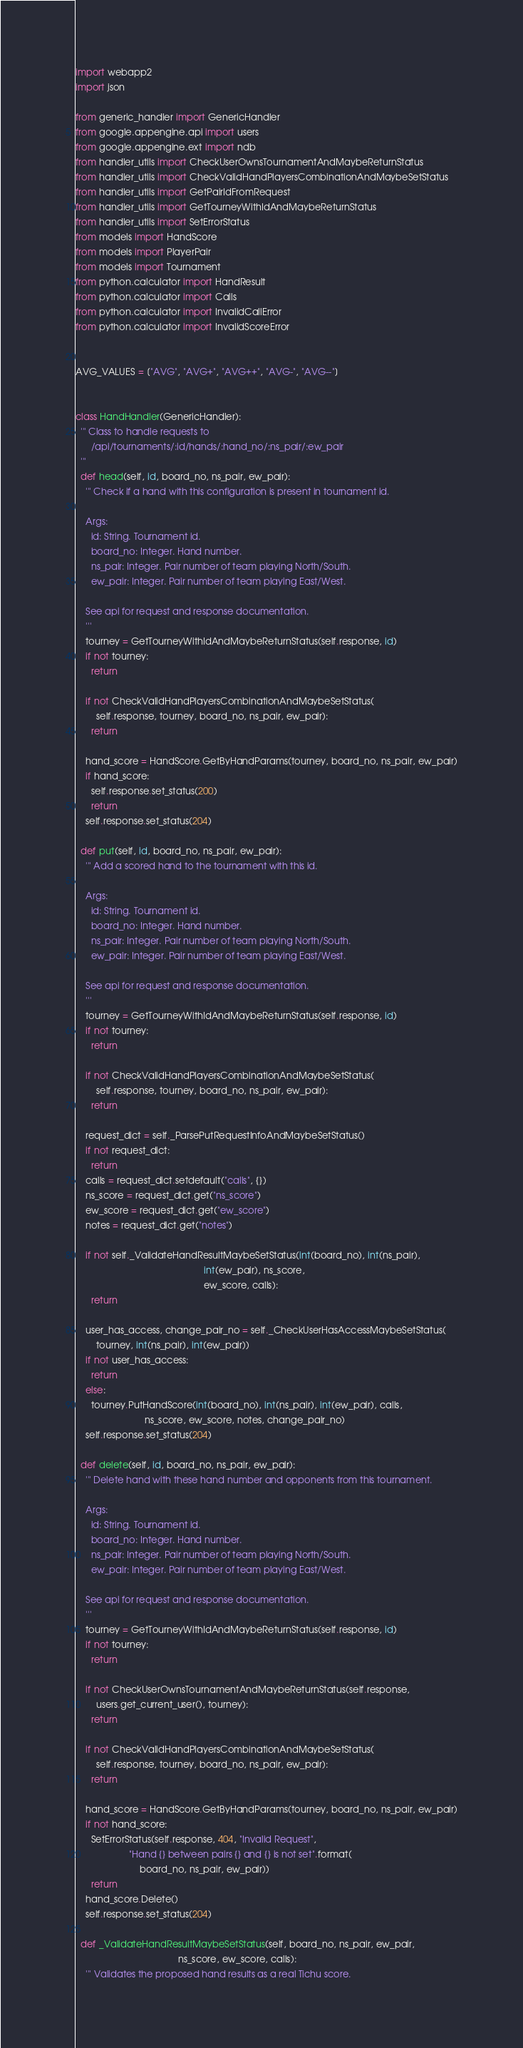Convert code to text. <code><loc_0><loc_0><loc_500><loc_500><_Python_>import webapp2
import json

from generic_handler import GenericHandler
from google.appengine.api import users
from google.appengine.ext import ndb
from handler_utils import CheckUserOwnsTournamentAndMaybeReturnStatus
from handler_utils import CheckValidHandPlayersCombinationAndMaybeSetStatus
from handler_utils import GetPairIdFromRequest
from handler_utils import GetTourneyWithIdAndMaybeReturnStatus
from handler_utils import SetErrorStatus
from models import HandScore
from models import PlayerPair
from models import Tournament
from python.calculator import HandResult
from python.calculator import Calls
from python.calculator import InvalidCallError
from python.calculator import InvalidScoreError


AVG_VALUES = ["AVG", "AVG+", "AVG++", "AVG-", "AVG--"]


class HandHandler(GenericHandler):
  ''' Class to handle requests to 
      /api/tournaments/:id/hands/:hand_no/:ns_pair/:ew_pair
  '''
  def head(self, id, board_no, ns_pair, ew_pair):
    ''' Check if a hand with this configuration is present in tournament id. 

    Args:
      id: String. Tournament id. 
      board_no: Integer. Hand number.
      ns_pair: Integer. Pair number of team playing North/South.
      ew_pair: Integer. Pair number of team playing East/West.

    See api for request and response documentation.
    '''
    tourney = GetTourneyWithIdAndMaybeReturnStatus(self.response, id)
    if not tourney:
      return

    if not CheckValidHandPlayersCombinationAndMaybeSetStatus(
        self.response, tourney, board_no, ns_pair, ew_pair):
      return

    hand_score = HandScore.GetByHandParams(tourney, board_no, ns_pair, ew_pair)
    if hand_score:
      self.response.set_status(200)
      return 
    self.response.set_status(204)

  def put(self, id, board_no, ns_pair, ew_pair):
    ''' Add a scored hand to the tournament with this id. 

    Args:
      id: String. Tournament id. 
      board_no: Integer. Hand number.
      ns_pair: Integer. Pair number of team playing North/South.
      ew_pair: Integer. Pair number of team playing East/West.
    
    See api for request and response documentation.
    '''
    tourney = GetTourneyWithIdAndMaybeReturnStatus(self.response, id)
    if not tourney:
      return

    if not CheckValidHandPlayersCombinationAndMaybeSetStatus(
        self.response, tourney, board_no, ns_pair, ew_pair):
      return

    request_dict = self._ParsePutRequestInfoAndMaybeSetStatus()
    if not request_dict:
      return
    calls = request_dict.setdefault("calls", {})
    ns_score = request_dict.get("ns_score")
    ew_score = request_dict.get("ew_score")
    notes = request_dict.get("notes")

    if not self._ValidateHandResultMaybeSetStatus(int(board_no), int(ns_pair),
                                                  int(ew_pair), ns_score,
                                                  ew_score, calls):
      return

    user_has_access, change_pair_no = self._CheckUserHasAccessMaybeSetStatus(
        tourney, int(ns_pair), int(ew_pair))
    if not user_has_access:
      return
    else:
      tourney.PutHandScore(int(board_no), int(ns_pair), int(ew_pair), calls,
                           ns_score, ew_score, notes, change_pair_no)
    self.response.set_status(204)

  def delete(self, id, board_no, ns_pair, ew_pair):
    ''' Delete hand with these hand number and opponents from this tournament.

    Args:
      id: String. Tournament id. 
      board_no: Integer. Hand number.
      ns_pair: Integer. Pair number of team playing North/South.
      ew_pair: Integer. Pair number of team playing East/West.
    
    See api for request and response documentation.
    '''
    tourney = GetTourneyWithIdAndMaybeReturnStatus(self.response, id)
    if not tourney:
      return

    if not CheckUserOwnsTournamentAndMaybeReturnStatus(self.response,
        users.get_current_user(), tourney):
      return

    if not CheckValidHandPlayersCombinationAndMaybeSetStatus(
        self.response, tourney, board_no, ns_pair, ew_pair):
      return

    hand_score = HandScore.GetByHandParams(tourney, board_no, ns_pair, ew_pair)
    if not hand_score:
      SetErrorStatus(self.response, 404, "Invalid Request",
                     "Hand {} between pairs {} and {} is not set".format(
                         board_no, ns_pair, ew_pair))
      return
    hand_score.Delete()
    self.response.set_status(204) 

  def _ValidateHandResultMaybeSetStatus(self, board_no, ns_pair, ew_pair,
                                        ns_score, ew_score, calls):
    ''' Validates the proposed hand results as a real Tichu score.
</code> 